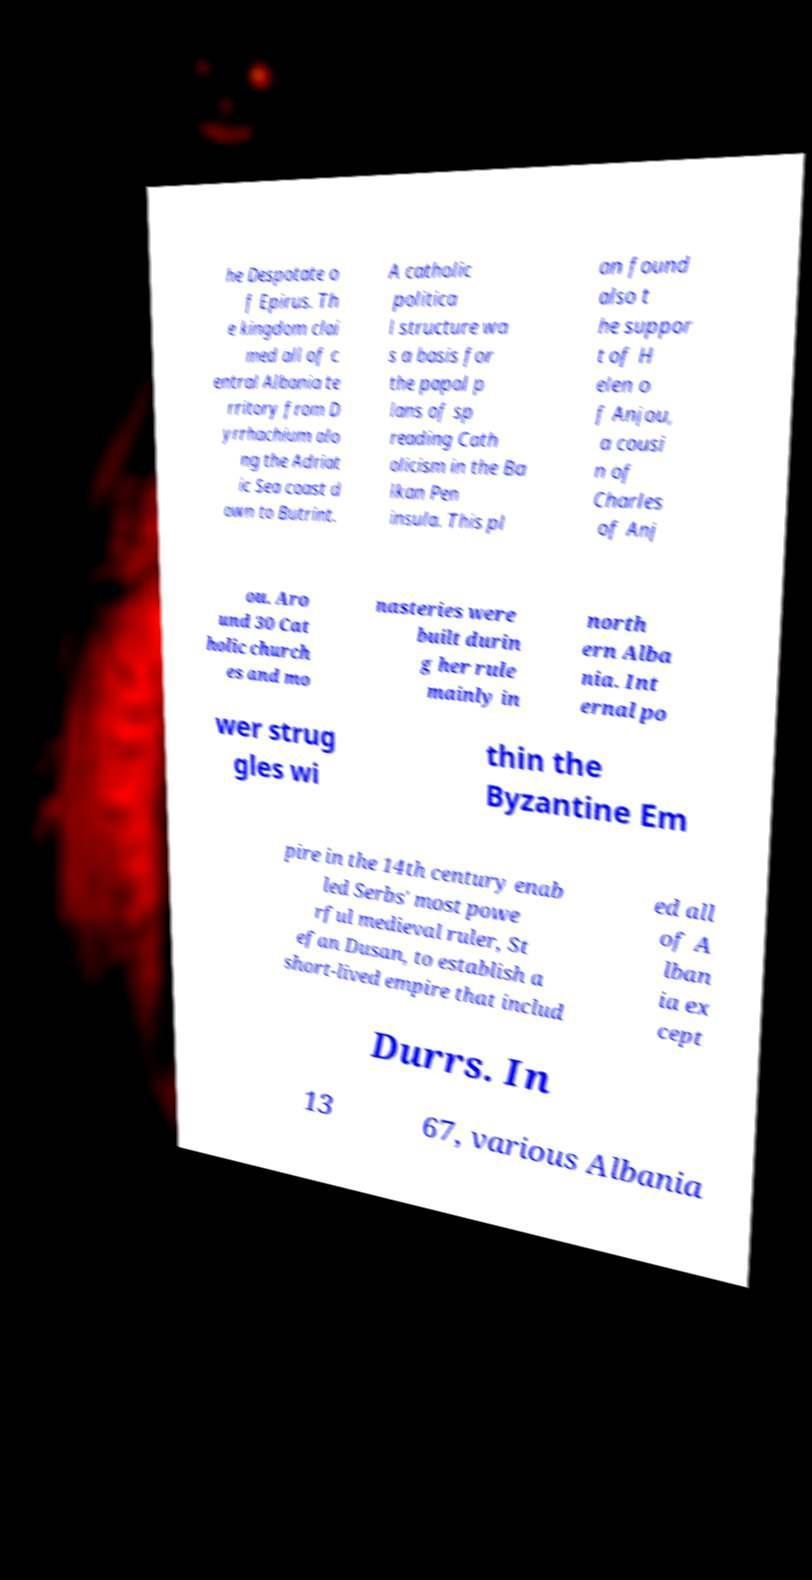Could you extract and type out the text from this image? he Despotate o f Epirus. Th e kingdom clai med all of c entral Albania te rritory from D yrrhachium alo ng the Adriat ic Sea coast d own to Butrint. A catholic politica l structure wa s a basis for the papal p lans of sp reading Cath olicism in the Ba lkan Pen insula. This pl an found also t he suppor t of H elen o f Anjou, a cousi n of Charles of Anj ou. Aro und 30 Cat holic church es and mo nasteries were built durin g her rule mainly in north ern Alba nia. Int ernal po wer strug gles wi thin the Byzantine Em pire in the 14th century enab led Serbs' most powe rful medieval ruler, St efan Dusan, to establish a short-lived empire that includ ed all of A lban ia ex cept Durrs. In 13 67, various Albania 